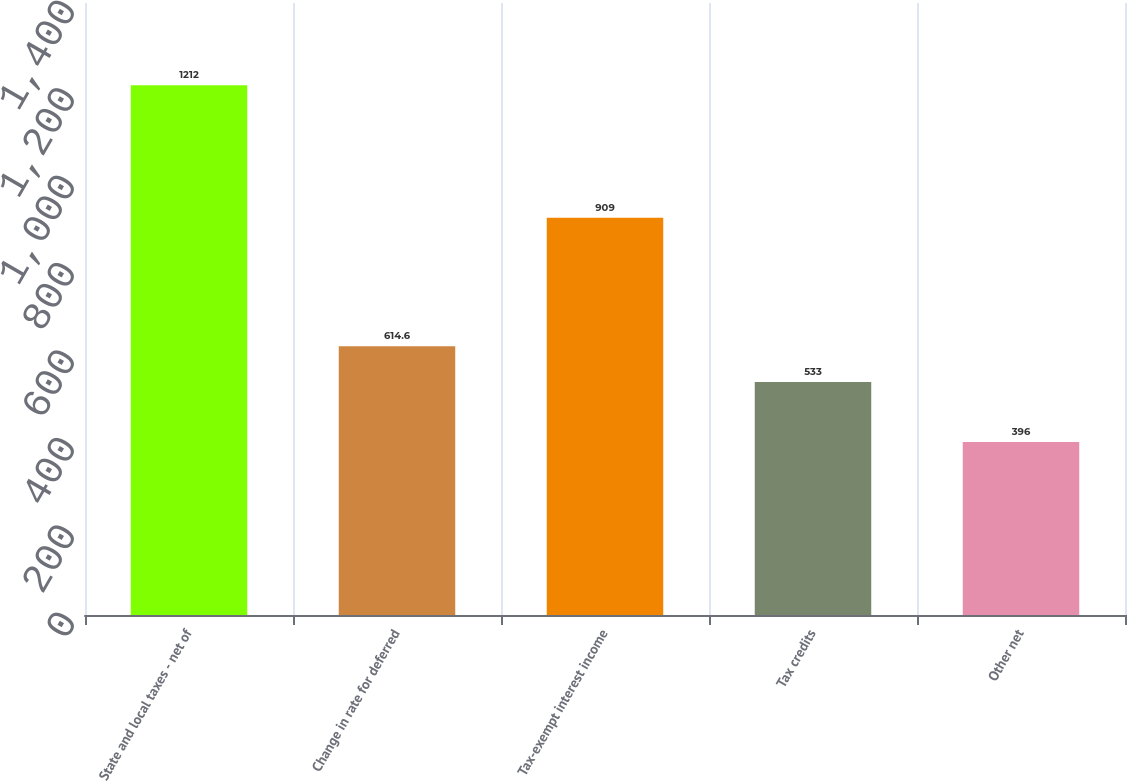Convert chart. <chart><loc_0><loc_0><loc_500><loc_500><bar_chart><fcel>State and local taxes - net of<fcel>Change in rate for deferred<fcel>Tax-exempt interest income<fcel>Tax credits<fcel>Other net<nl><fcel>1212<fcel>614.6<fcel>909<fcel>533<fcel>396<nl></chart> 